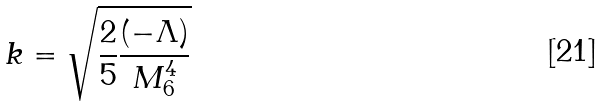Convert formula to latex. <formula><loc_0><loc_0><loc_500><loc_500>k = \sqrt { \frac { 2 } { 5 } \frac { ( - \Lambda ) } { M _ { 6 } ^ { 4 } } }</formula> 